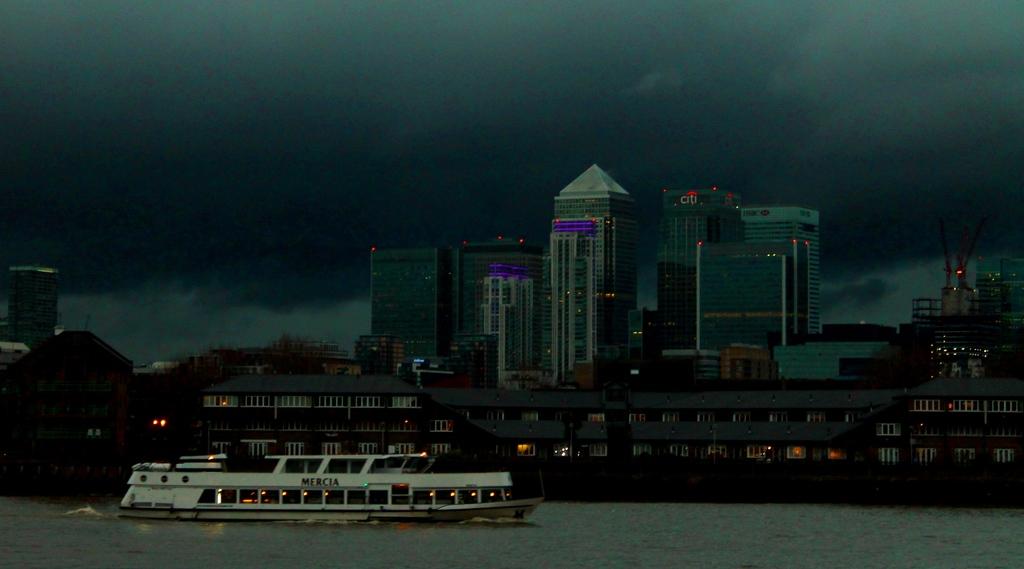What name is on the ship?
Make the answer very short. Mercia. What financial company is advertised on a building?
Keep it short and to the point. Citi. 